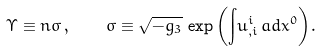Convert formula to latex. <formula><loc_0><loc_0><loc_500><loc_500>\Upsilon \equiv n \sigma \, , \quad \sigma \equiv \sqrt { - g _ { 3 } } \, \exp { \left ( { \int } u ^ { i } _ { , i } \, a d x ^ { 0 } \right ) } .</formula> 